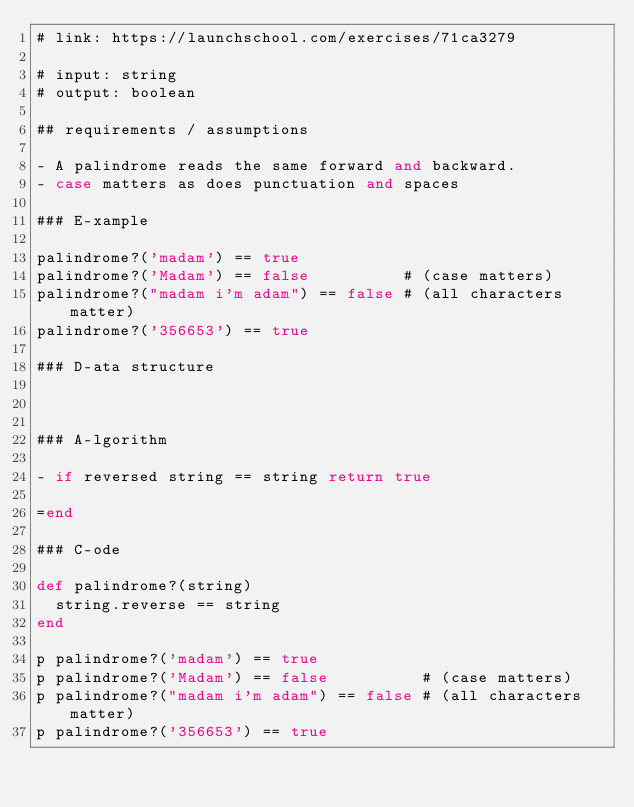<code> <loc_0><loc_0><loc_500><loc_500><_Ruby_># link: https://launchschool.com/exercises/71ca3279

# input: string
# output: boolean

## requirements / assumptions

- A palindrome reads the same forward and backward.
- case matters as does punctuation and spaces

### E-xample

palindrome?('madam') == true
palindrome?('Madam') == false          # (case matters)
palindrome?("madam i'm adam") == false # (all characters matter)
palindrome?('356653') == true

### D-ata structure



### A-lgorithm

- if reversed string == string return true

=end

### C-ode

def palindrome?(string)
  string.reverse == string
end

p palindrome?('madam') == true
p palindrome?('Madam') == false          # (case matters)
p palindrome?("madam i'm adam") == false # (all characters matter)
p palindrome?('356653') == true
</code> 